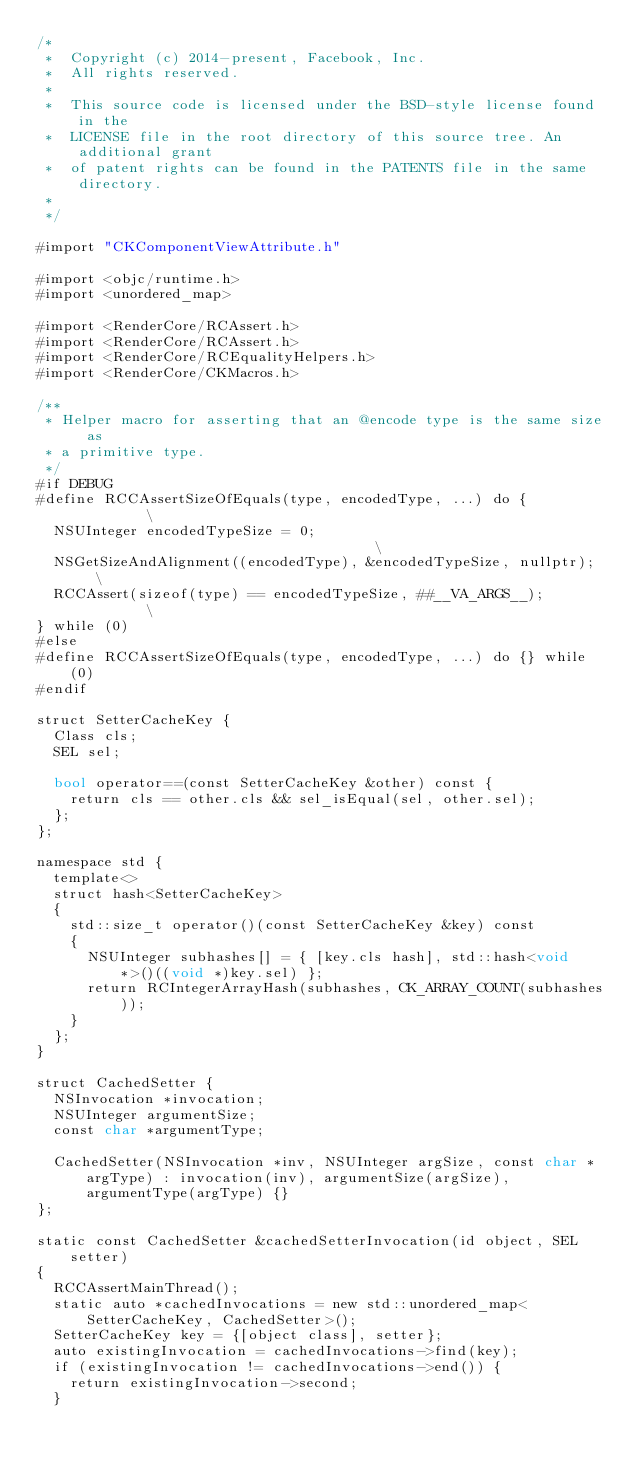Convert code to text. <code><loc_0><loc_0><loc_500><loc_500><_ObjectiveC_>/*
 *  Copyright (c) 2014-present, Facebook, Inc.
 *  All rights reserved.
 *
 *  This source code is licensed under the BSD-style license found in the
 *  LICENSE file in the root directory of this source tree. An additional grant
 *  of patent rights can be found in the PATENTS file in the same directory.
 *
 */

#import "CKComponentViewAttribute.h"

#import <objc/runtime.h>
#import <unordered_map>

#import <RenderCore/RCAssert.h>
#import <RenderCore/RCAssert.h>
#import <RenderCore/RCEqualityHelpers.h>
#import <RenderCore/CKMacros.h>

/**
 * Helper macro for asserting that an @encode type is the same size as
 * a primitive type.
 */
#if DEBUG
#define RCCAssertSizeOfEquals(type, encodedType, ...) do {          \
  NSUInteger encodedTypeSize = 0;                                   \
  NSGetSizeAndAlignment((encodedType), &encodedTypeSize, nullptr);  \
  RCCAssert(sizeof(type) == encodedTypeSize, ##__VA_ARGS__);        \
} while (0)
#else
#define RCCAssertSizeOfEquals(type, encodedType, ...) do {} while(0)
#endif

struct SetterCacheKey {
  Class cls;
  SEL sel;

  bool operator==(const SetterCacheKey &other) const {
    return cls == other.cls && sel_isEqual(sel, other.sel);
  };
};

namespace std {
  template<>
  struct hash<SetterCacheKey>
  {
    std::size_t operator()(const SetterCacheKey &key) const
    {
      NSUInteger subhashes[] = { [key.cls hash], std::hash<void *>()((void *)key.sel) };
      return RCIntegerArrayHash(subhashes, CK_ARRAY_COUNT(subhashes));
    }
  };
}

struct CachedSetter {
  NSInvocation *invocation;
  NSUInteger argumentSize;
  const char *argumentType;

  CachedSetter(NSInvocation *inv, NSUInteger argSize, const char *argType) : invocation(inv), argumentSize(argSize), argumentType(argType) {}
};

static const CachedSetter &cachedSetterInvocation(id object, SEL setter)
{
  RCCAssertMainThread();
  static auto *cachedInvocations = new std::unordered_map<SetterCacheKey, CachedSetter>();
  SetterCacheKey key = {[object class], setter};
  auto existingInvocation = cachedInvocations->find(key);
  if (existingInvocation != cachedInvocations->end()) {
    return existingInvocation->second;
  }
</code> 